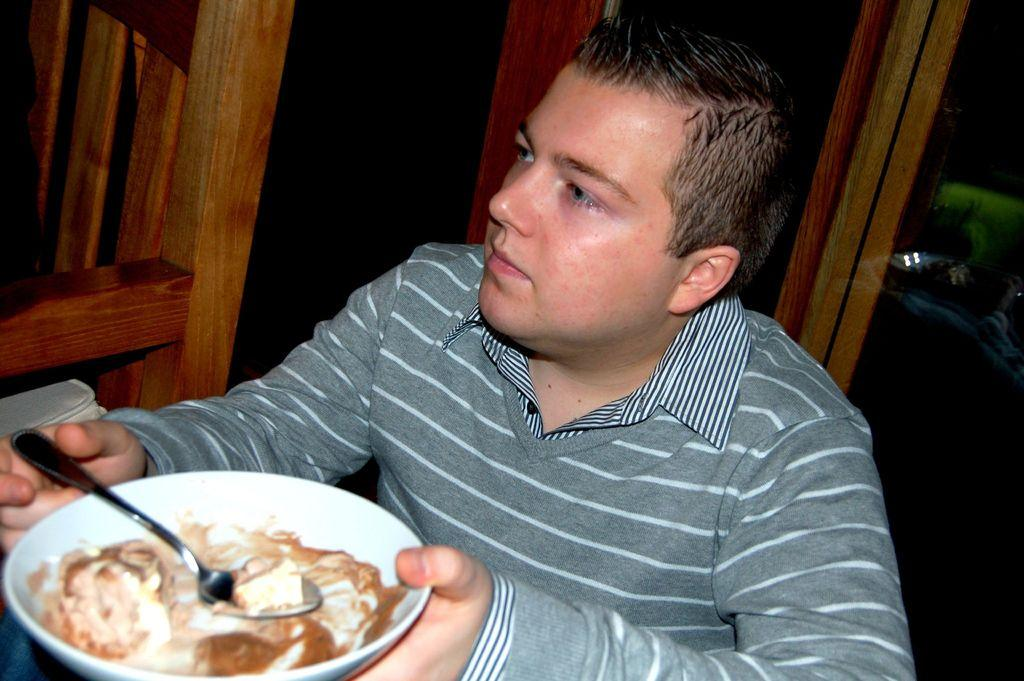What is the person in the image holding? The person is holding a plate in the image. What is on the plate that the person is holding? There is a food item on the plate. What can be seen in the background of the image? There are wooden objects in the background of the image. What type of badge is the person wearing in the image? There is no badge visible in the image; the person is only holding a plate with a food item on it. 